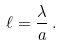<formula> <loc_0><loc_0><loc_500><loc_500>\ell = \frac { \lambda } { a } \, .</formula> 